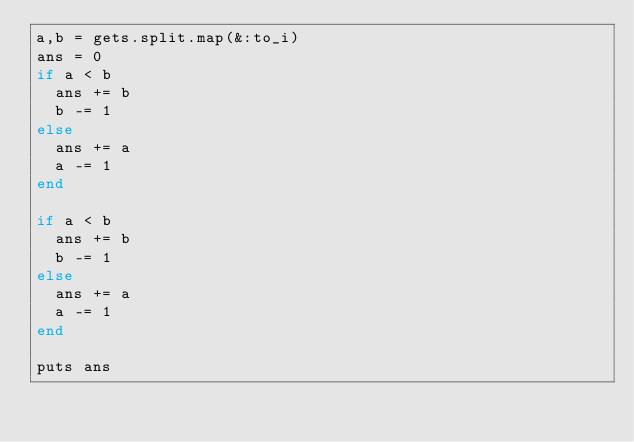<code> <loc_0><loc_0><loc_500><loc_500><_Ruby_>a,b = gets.split.map(&:to_i)
ans = 0
if a < b
  ans += b
  b -= 1
else
  ans += a
  a -= 1
end

if a < b
  ans += b
  b -= 1
else
  ans += a
  a -= 1
end

puts ans</code> 